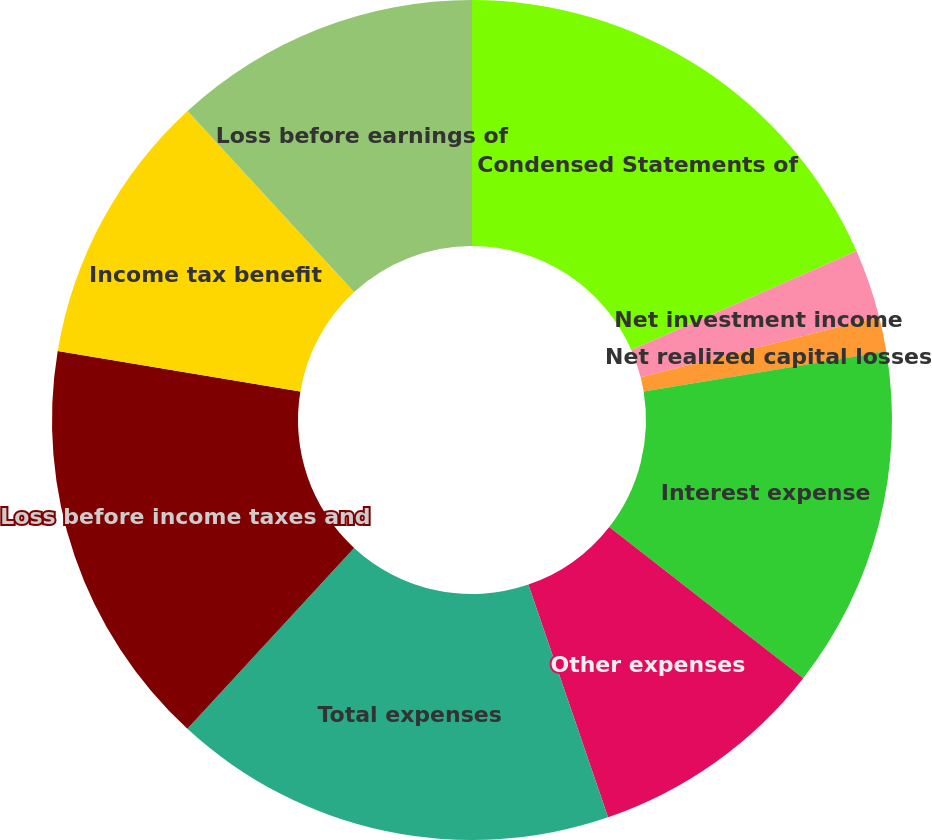Convert chart to OTSL. <chart><loc_0><loc_0><loc_500><loc_500><pie_chart><fcel>Condensed Statements of<fcel>Net investment income<fcel>Net realized capital losses<fcel>Total revenues<fcel>Interest expense<fcel>Other expenses<fcel>Total expenses<fcel>Loss before income taxes and<fcel>Income tax benefit<fcel>Loss before earnings of<nl><fcel>18.41%<fcel>2.64%<fcel>1.33%<fcel>0.01%<fcel>13.15%<fcel>9.21%<fcel>17.1%<fcel>15.78%<fcel>10.53%<fcel>11.84%<nl></chart> 